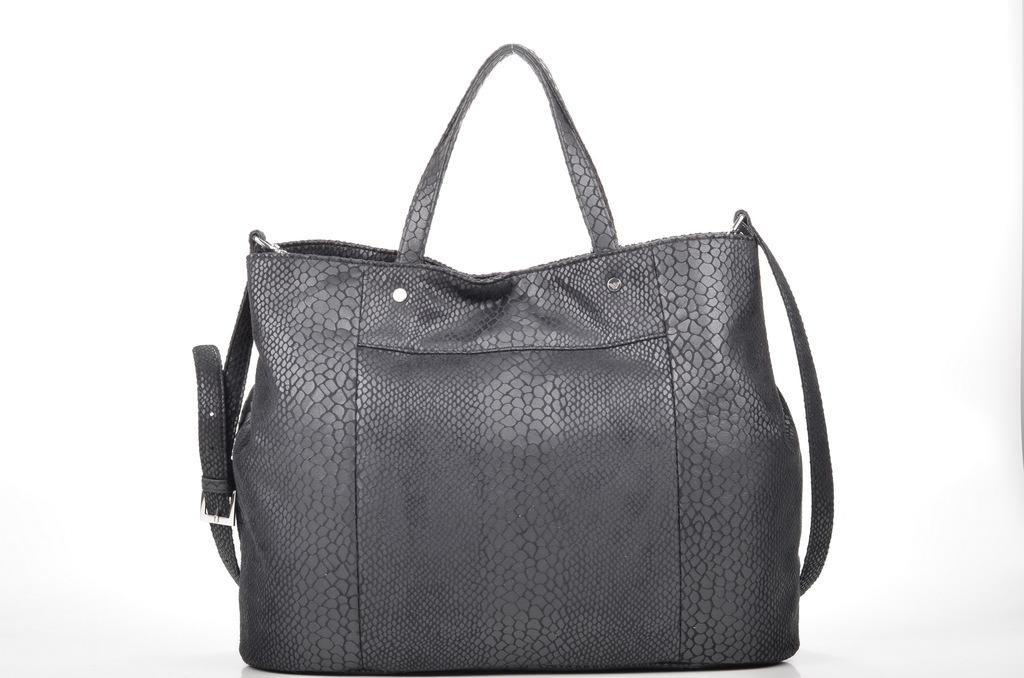What type of accessory is visible in the image? There is a black handbag in the image. What type of knife is being used to cut the handbag in the image? There is no knife or any indication of cutting in the image; it only features a black handbag. 